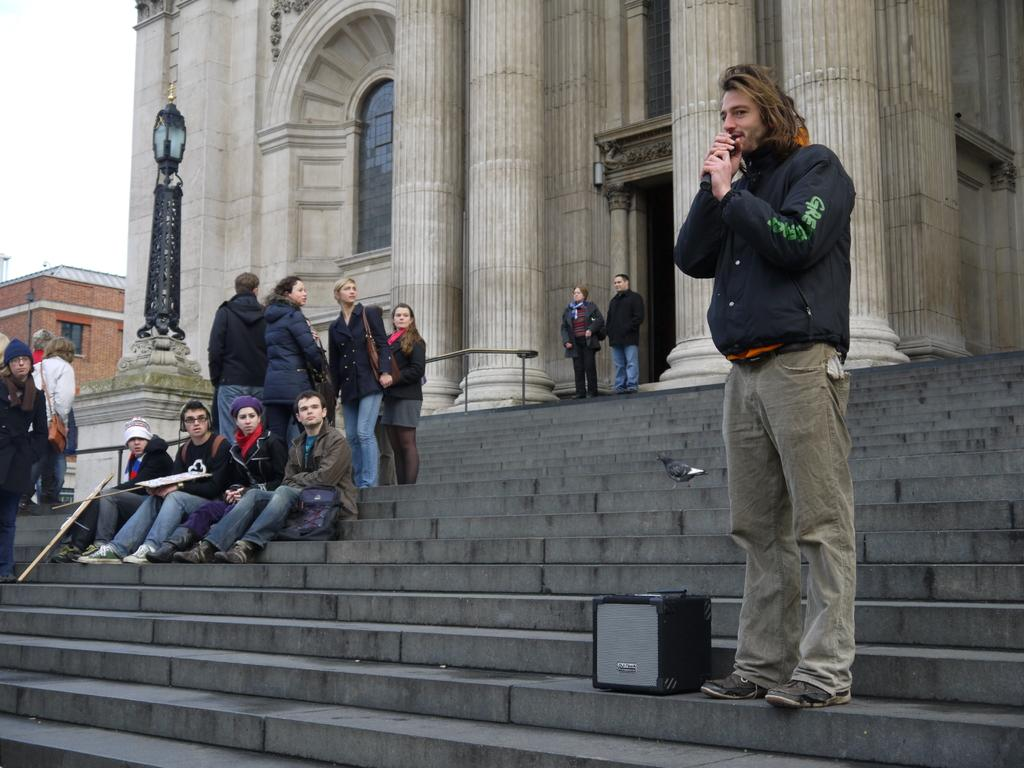How many people are in the image? There is a group of people in the image. What are some of the people in the image doing? Some people are sitting, and some people are standing. What can be seen in the background of the image? There are buildings in the background of the image. What color are the eyes of the person in the image? There is no specific person mentioned in the image, and no information about their eyes is provided. 